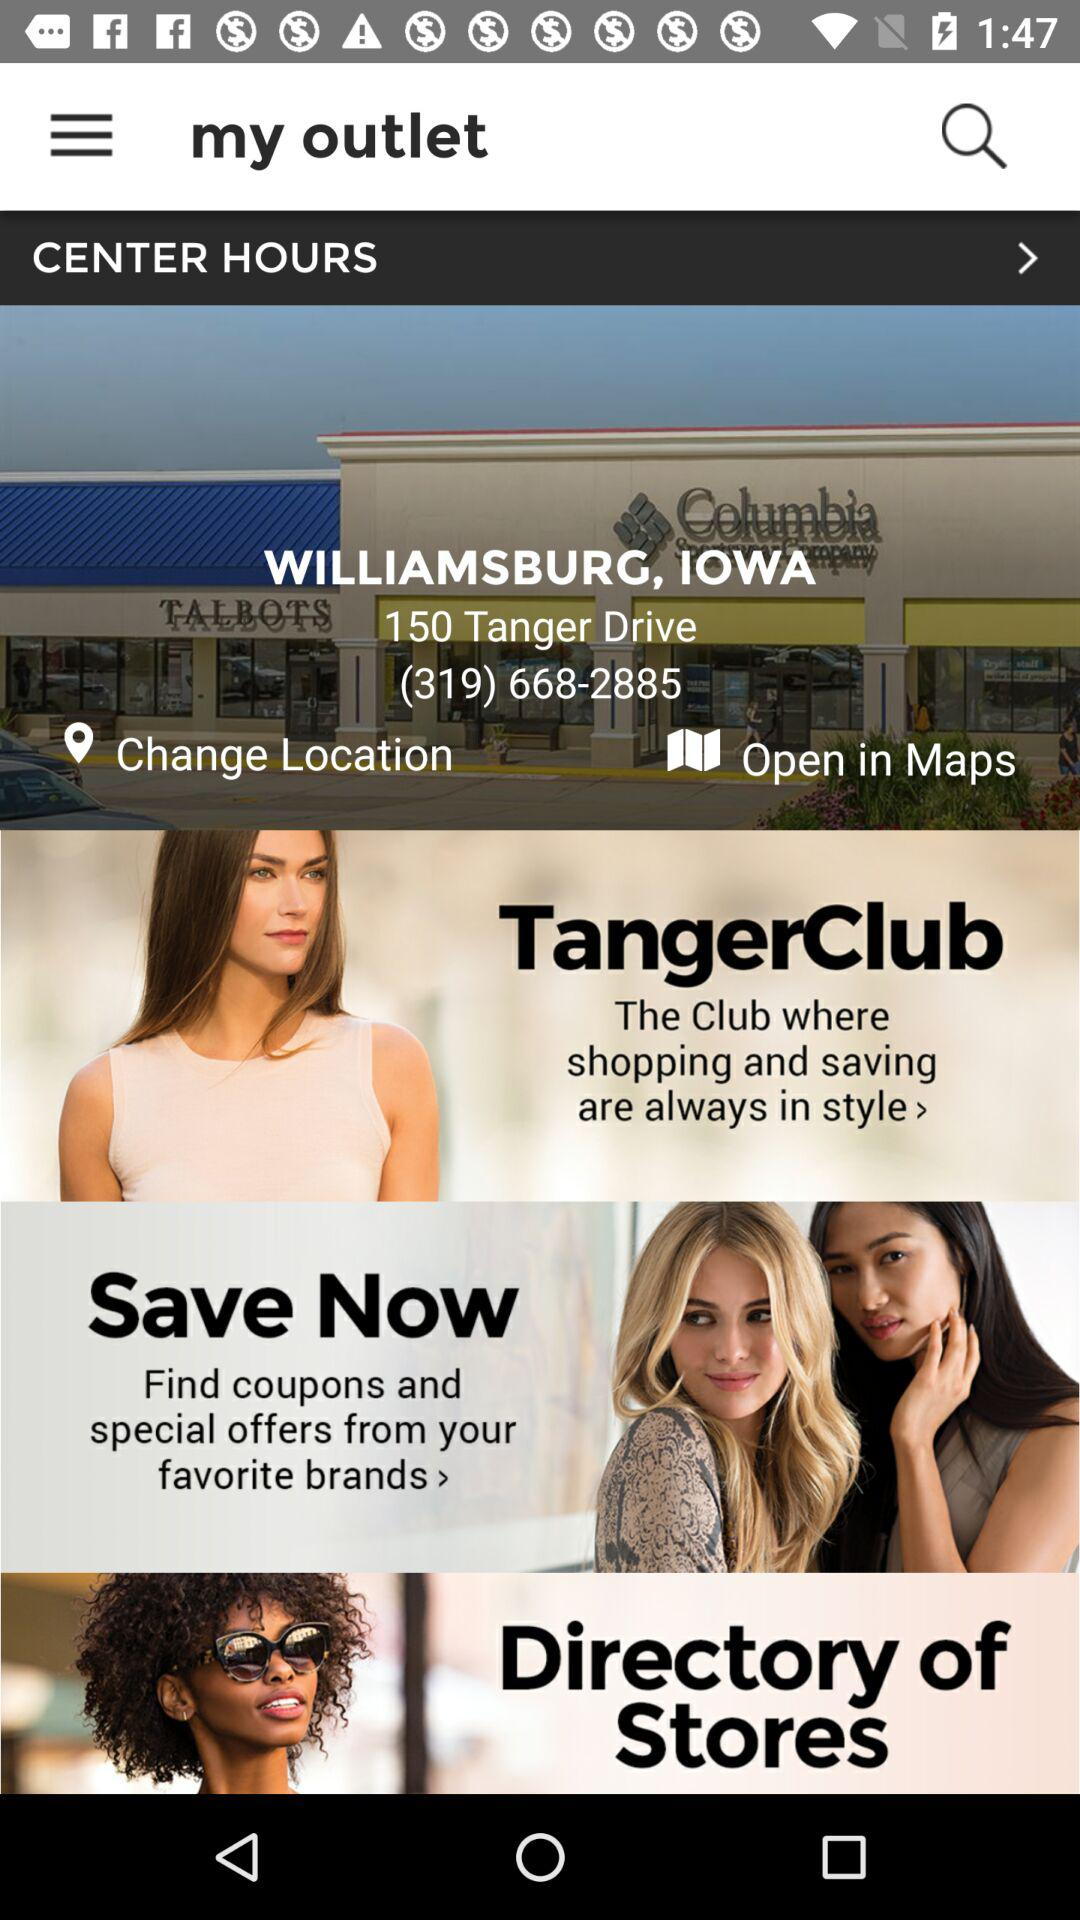What is the location? The location is Williamsburg, Iowa. 